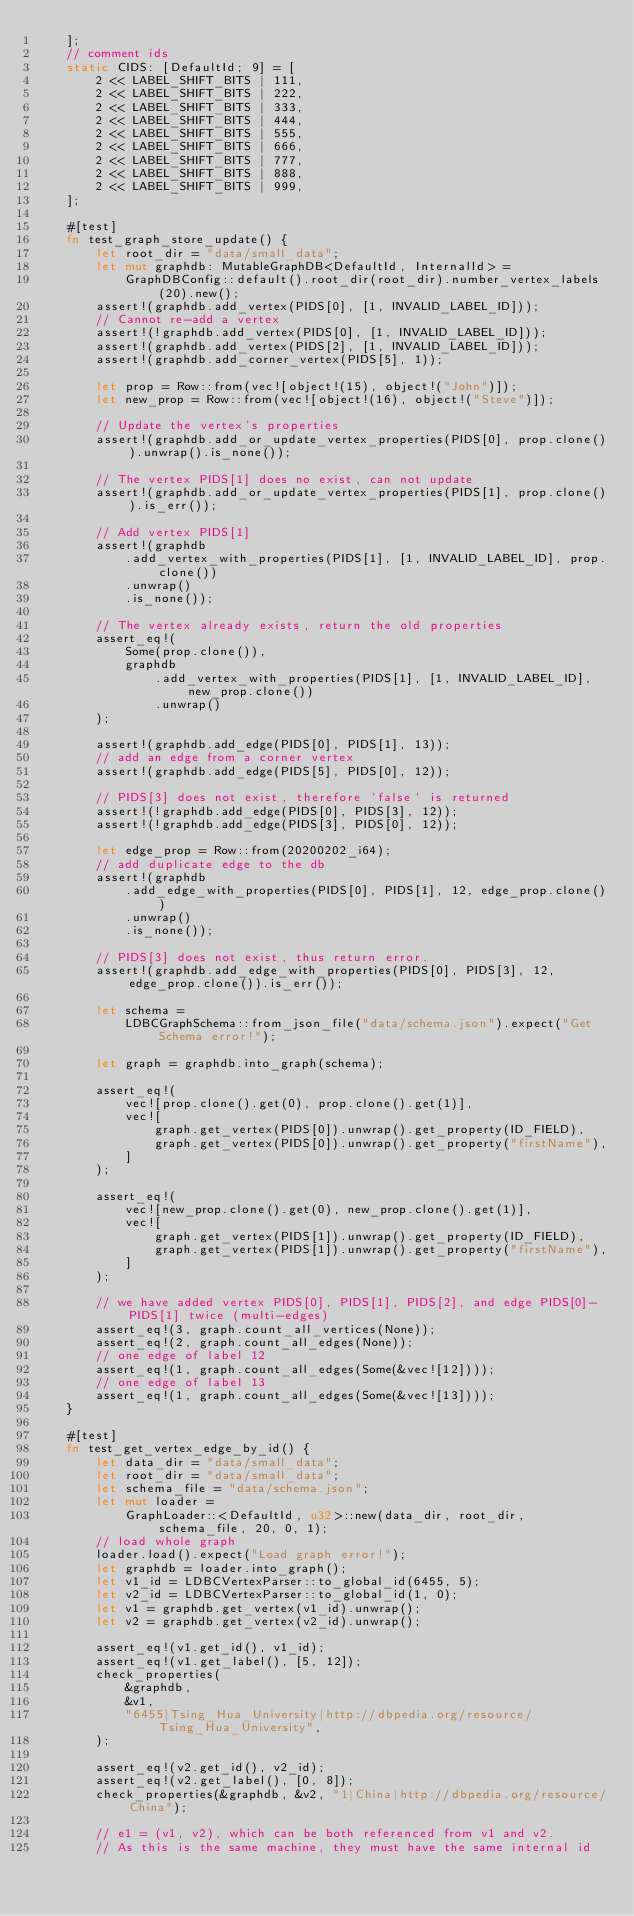<code> <loc_0><loc_0><loc_500><loc_500><_Rust_>    ];
    // comment ids
    static CIDS: [DefaultId; 9] = [
        2 << LABEL_SHIFT_BITS | 111,
        2 << LABEL_SHIFT_BITS | 222,
        2 << LABEL_SHIFT_BITS | 333,
        2 << LABEL_SHIFT_BITS | 444,
        2 << LABEL_SHIFT_BITS | 555,
        2 << LABEL_SHIFT_BITS | 666,
        2 << LABEL_SHIFT_BITS | 777,
        2 << LABEL_SHIFT_BITS | 888,
        2 << LABEL_SHIFT_BITS | 999,
    ];

    #[test]
    fn test_graph_store_update() {
        let root_dir = "data/small_data";
        let mut graphdb: MutableGraphDB<DefaultId, InternalId> =
            GraphDBConfig::default().root_dir(root_dir).number_vertex_labels(20).new();
        assert!(graphdb.add_vertex(PIDS[0], [1, INVALID_LABEL_ID]));
        // Cannot re-add a vertex
        assert!(!graphdb.add_vertex(PIDS[0], [1, INVALID_LABEL_ID]));
        assert!(graphdb.add_vertex(PIDS[2], [1, INVALID_LABEL_ID]));
        assert!(graphdb.add_corner_vertex(PIDS[5], 1));

        let prop = Row::from(vec![object!(15), object!("John")]);
        let new_prop = Row::from(vec![object!(16), object!("Steve")]);

        // Update the vertex's properties
        assert!(graphdb.add_or_update_vertex_properties(PIDS[0], prop.clone()).unwrap().is_none());

        // The vertex PIDS[1] does no exist, can not update
        assert!(graphdb.add_or_update_vertex_properties(PIDS[1], prop.clone()).is_err());

        // Add vertex PIDS[1]
        assert!(graphdb
            .add_vertex_with_properties(PIDS[1], [1, INVALID_LABEL_ID], prop.clone())
            .unwrap()
            .is_none());

        // The vertex already exists, return the old properties
        assert_eq!(
            Some(prop.clone()),
            graphdb
                .add_vertex_with_properties(PIDS[1], [1, INVALID_LABEL_ID], new_prop.clone())
                .unwrap()
        );

        assert!(graphdb.add_edge(PIDS[0], PIDS[1], 13));
        // add an edge from a corner vertex
        assert!(graphdb.add_edge(PIDS[5], PIDS[0], 12));

        // PIDS[3] does not exist, therefore `false` is returned
        assert!(!graphdb.add_edge(PIDS[0], PIDS[3], 12));
        assert!(!graphdb.add_edge(PIDS[3], PIDS[0], 12));

        let edge_prop = Row::from(20200202_i64);
        // add duplicate edge to the db
        assert!(graphdb
            .add_edge_with_properties(PIDS[0], PIDS[1], 12, edge_prop.clone())
            .unwrap()
            .is_none());

        // PIDS[3] does not exist, thus return error.
        assert!(graphdb.add_edge_with_properties(PIDS[0], PIDS[3], 12, edge_prop.clone()).is_err());

        let schema =
            LDBCGraphSchema::from_json_file("data/schema.json").expect("Get Schema error!");

        let graph = graphdb.into_graph(schema);

        assert_eq!(
            vec![prop.clone().get(0), prop.clone().get(1)],
            vec![
                graph.get_vertex(PIDS[0]).unwrap().get_property(ID_FIELD),
                graph.get_vertex(PIDS[0]).unwrap().get_property("firstName"),
            ]
        );

        assert_eq!(
            vec![new_prop.clone().get(0), new_prop.clone().get(1)],
            vec![
                graph.get_vertex(PIDS[1]).unwrap().get_property(ID_FIELD),
                graph.get_vertex(PIDS[1]).unwrap().get_property("firstName"),
            ]
        );

        // we have added vertex PIDS[0], PIDS[1], PIDS[2], and edge PIDS[0]-PIDS[1] twice (multi-edges)
        assert_eq!(3, graph.count_all_vertices(None));
        assert_eq!(2, graph.count_all_edges(None));
        // one edge of label 12
        assert_eq!(1, graph.count_all_edges(Some(&vec![12])));
        // one edge of label 13
        assert_eq!(1, graph.count_all_edges(Some(&vec![13])));
    }

    #[test]
    fn test_get_vertex_edge_by_id() {
        let data_dir = "data/small_data";
        let root_dir = "data/small_data";
        let schema_file = "data/schema.json";
        let mut loader =
            GraphLoader::<DefaultId, u32>::new(data_dir, root_dir, schema_file, 20, 0, 1);
        // load whole graph
        loader.load().expect("Load graph error!");
        let graphdb = loader.into_graph();
        let v1_id = LDBCVertexParser::to_global_id(6455, 5);
        let v2_id = LDBCVertexParser::to_global_id(1, 0);
        let v1 = graphdb.get_vertex(v1_id).unwrap();
        let v2 = graphdb.get_vertex(v2_id).unwrap();

        assert_eq!(v1.get_id(), v1_id);
        assert_eq!(v1.get_label(), [5, 12]);
        check_properties(
            &graphdb,
            &v1,
            "6455|Tsing_Hua_University|http://dbpedia.org/resource/Tsing_Hua_University",
        );

        assert_eq!(v2.get_id(), v2_id);
        assert_eq!(v2.get_label(), [0, 8]);
        check_properties(&graphdb, &v2, "1|China|http://dbpedia.org/resource/China");

        // e1 = (v1, v2), which can be both referenced from v1 and v2.
        // As this is the same machine, they must have the same internal id</code> 